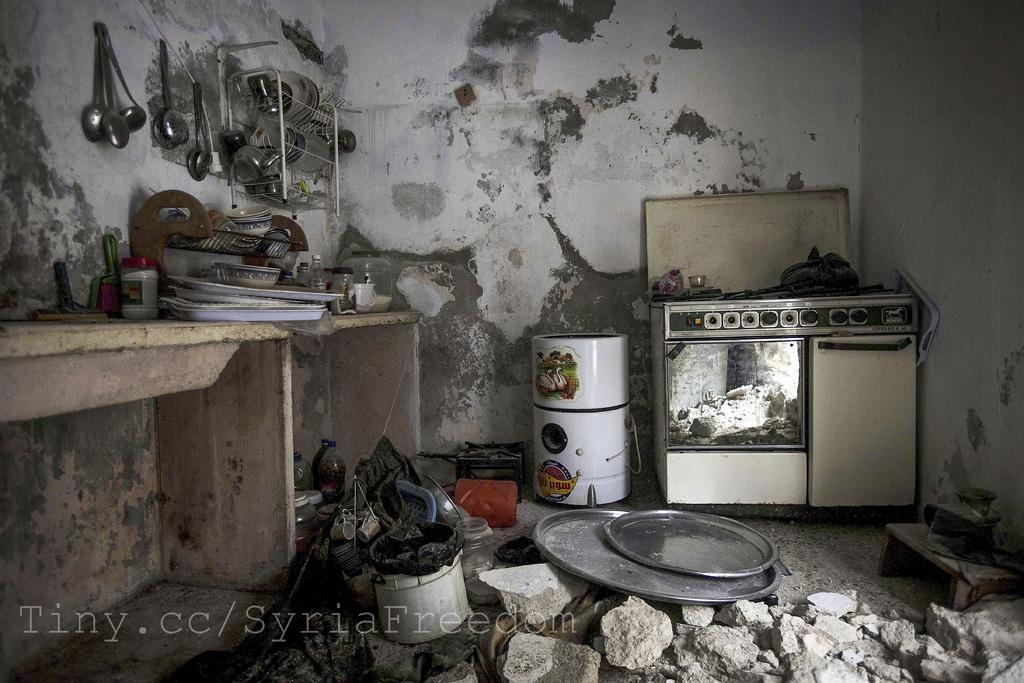In one or two sentences, can you explain what this image depicts? In this image we can see a cooking utensils, oven and objects. A wall of the house is painted with white color. 